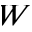<formula> <loc_0><loc_0><loc_500><loc_500>W</formula> 